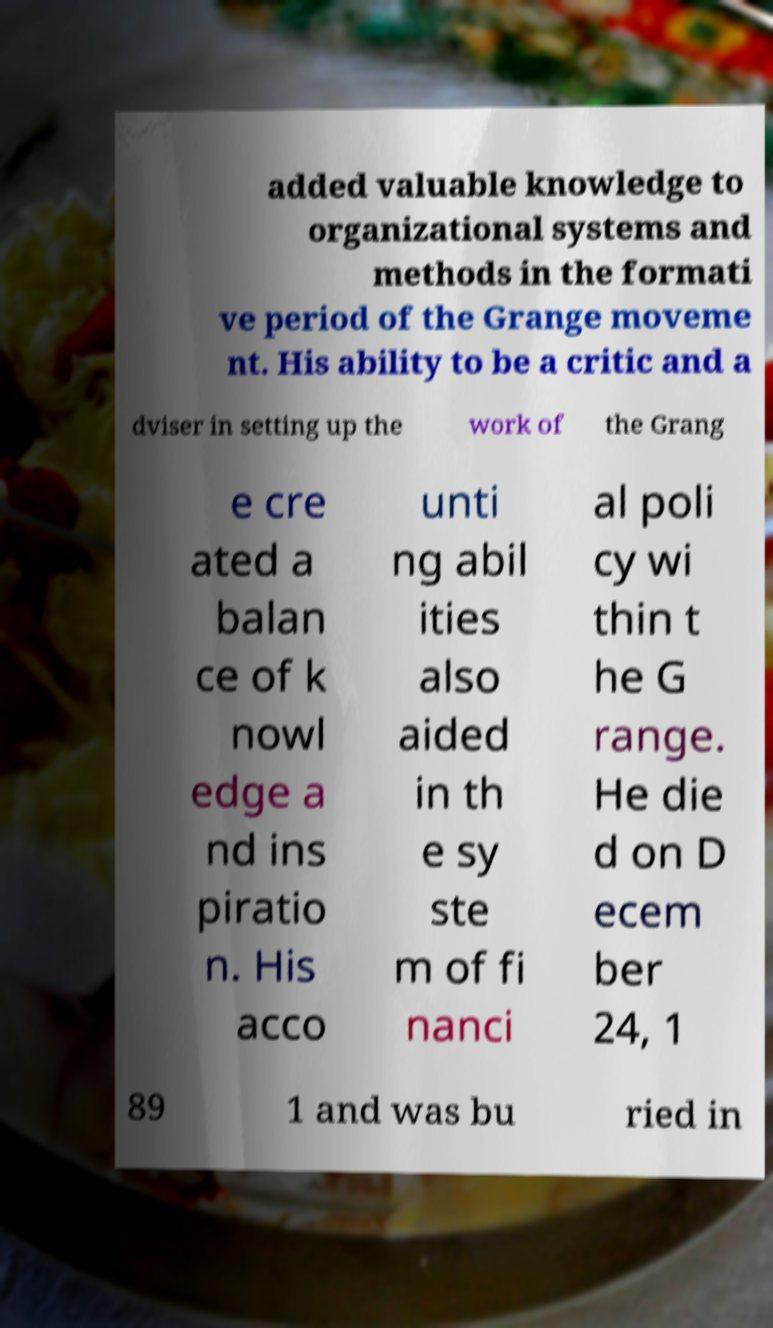There's text embedded in this image that I need extracted. Can you transcribe it verbatim? added valuable knowledge to organizational systems and methods in the formati ve period of the Grange moveme nt. His ability to be a critic and a dviser in setting up the work of the Grang e cre ated a balan ce of k nowl edge a nd ins piratio n. His acco unti ng abil ities also aided in th e sy ste m of fi nanci al poli cy wi thin t he G range. He die d on D ecem ber 24, 1 89 1 and was bu ried in 